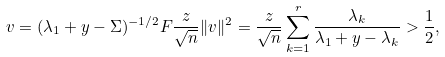Convert formula to latex. <formula><loc_0><loc_0><loc_500><loc_500>v = ( \lambda _ { 1 } + y - \Sigma ) ^ { - 1 / 2 } F \frac { z } { \sqrt { n } } \| v \| ^ { 2 } = \frac { z } { \sqrt { n } } \sum _ { k = 1 } ^ { r } \frac { \lambda _ { k } } { \lambda _ { 1 } + y - \lambda _ { k } } > \frac { 1 } { 2 } ,</formula> 